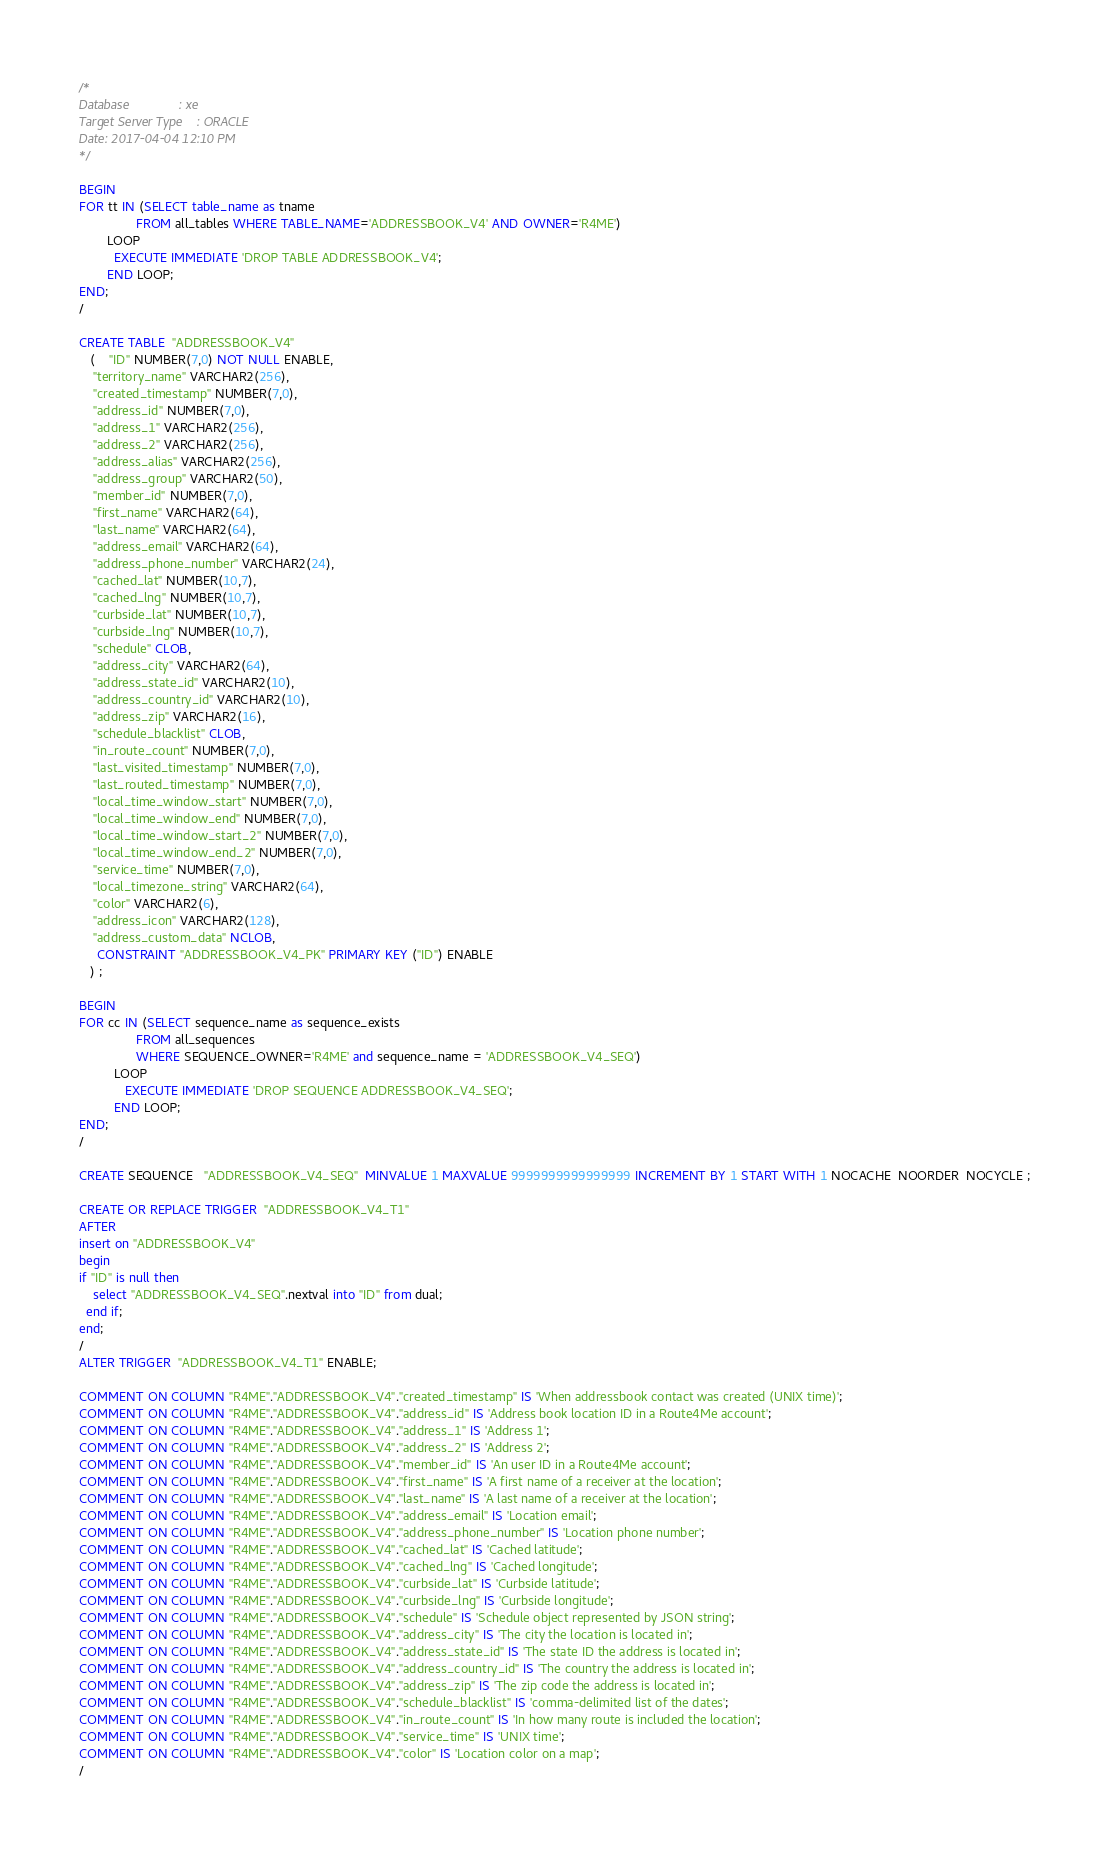Convert code to text. <code><loc_0><loc_0><loc_500><loc_500><_SQL_>/*
Database              : xe
Target Server Type    : ORACLE
Date: 2017-04-04 12:10 PM
*/

BEGIN
FOR tt IN (SELECT table_name as tname
                FROM all_tables WHERE TABLE_NAME='ADDRESSBOOK_V4' AND OWNER='R4ME')
        LOOP
          EXECUTE IMMEDIATE 'DROP TABLE ADDRESSBOOK_V4';
        END LOOP;
END;
/

CREATE TABLE  "ADDRESSBOOK_V4" 
   (	"ID" NUMBER(7,0) NOT NULL ENABLE, 
	"territory_name" VARCHAR2(256), 
	"created_timestamp" NUMBER(7,0), 
	"address_id" NUMBER(7,0), 
	"address_1" VARCHAR2(256), 
	"address_2" VARCHAR2(256), 
	"address_alias" VARCHAR2(256), 
	"address_group" VARCHAR2(50), 
	"member_id" NUMBER(7,0), 
	"first_name" VARCHAR2(64), 
	"last_name" VARCHAR2(64), 
	"address_email" VARCHAR2(64), 
	"address_phone_number" VARCHAR2(24), 
	"cached_lat" NUMBER(10,7), 
	"cached_lng" NUMBER(10,7), 
	"curbside_lat" NUMBER(10,7), 
	"curbside_lng" NUMBER(10,7), 
	"schedule" CLOB, 
	"address_city" VARCHAR2(64), 
	"address_state_id" VARCHAR2(10), 
	"address_country_id" VARCHAR2(10), 
	"address_zip" VARCHAR2(16), 
	"schedule_blacklist" CLOB, 
	"in_route_count" NUMBER(7,0), 
	"last_visited_timestamp" NUMBER(7,0), 
	"last_routed_timestamp" NUMBER(7,0), 
	"local_time_window_start" NUMBER(7,0), 
	"local_time_window_end" NUMBER(7,0), 
	"local_time_window_start_2" NUMBER(7,0), 
	"local_time_window_end_2" NUMBER(7,0), 
	"service_time" NUMBER(7,0), 
	"local_timezone_string" VARCHAR2(64), 
	"color" VARCHAR2(6), 
	"address_icon" VARCHAR2(128), 
	"address_custom_data" NCLOB, 
	 CONSTRAINT "ADDRESSBOOK_V4_PK" PRIMARY KEY ("ID") ENABLE
   ) ;
   
BEGIN
FOR cc IN (SELECT sequence_name as sequence_exists 
                FROM all_sequences
                WHERE SEQUENCE_OWNER='R4ME' and sequence_name = 'ADDRESSBOOK_V4_SEQ')
          LOOP
             EXECUTE IMMEDIATE 'DROP SEQUENCE ADDRESSBOOK_V4_SEQ';
          END LOOP;
END;
/

CREATE SEQUENCE   "ADDRESSBOOK_V4_SEQ"  MINVALUE 1 MAXVALUE 9999999999999999 INCREMENT BY 1 START WITH 1 NOCACHE  NOORDER  NOCYCLE ;
   
CREATE OR REPLACE TRIGGER  "ADDRESSBOOK_V4_T1" 
AFTER
insert on "ADDRESSBOOK_V4"
begin
if "ID" is null then 
    select "ADDRESSBOOK_V4_SEQ".nextval into "ID" from dual; 
  end if; 
end;
/
ALTER TRIGGER  "ADDRESSBOOK_V4_T1" ENABLE;

COMMENT ON COLUMN "R4ME"."ADDRESSBOOK_V4"."created_timestamp" IS 'When addressbook contact was created (UNIX time)';
COMMENT ON COLUMN "R4ME"."ADDRESSBOOK_V4"."address_id" IS 'Address book location ID in a Route4Me account';
COMMENT ON COLUMN "R4ME"."ADDRESSBOOK_V4"."address_1" IS 'Address 1';
COMMENT ON COLUMN "R4ME"."ADDRESSBOOK_V4"."address_2" IS 'Address 2';
COMMENT ON COLUMN "R4ME"."ADDRESSBOOK_V4"."member_id" IS 'An user ID in a Route4Me account';
COMMENT ON COLUMN "R4ME"."ADDRESSBOOK_V4"."first_name" IS 'A first name of a receiver at the location';
COMMENT ON COLUMN "R4ME"."ADDRESSBOOK_V4"."last_name" IS 'A last name of a receiver at the location';
COMMENT ON COLUMN "R4ME"."ADDRESSBOOK_V4"."address_email" IS 'Location email';
COMMENT ON COLUMN "R4ME"."ADDRESSBOOK_V4"."address_phone_number" IS 'Location phone number';
COMMENT ON COLUMN "R4ME"."ADDRESSBOOK_V4"."cached_lat" IS 'Cached latitude';
COMMENT ON COLUMN "R4ME"."ADDRESSBOOK_V4"."cached_lng" IS 'Cached longitude';
COMMENT ON COLUMN "R4ME"."ADDRESSBOOK_V4"."curbside_lat" IS 'Curbside latitude';
COMMENT ON COLUMN "R4ME"."ADDRESSBOOK_V4"."curbside_lng" IS 'Curbside longitude';
COMMENT ON COLUMN "R4ME"."ADDRESSBOOK_V4"."schedule" IS 'Schedule object represented by JSON string';
COMMENT ON COLUMN "R4ME"."ADDRESSBOOK_V4"."address_city" IS 'The city the location is located in';
COMMENT ON COLUMN "R4ME"."ADDRESSBOOK_V4"."address_state_id" IS 'The state ID the address is located in';
COMMENT ON COLUMN "R4ME"."ADDRESSBOOK_V4"."address_country_id" IS 'The country the address is located in';
COMMENT ON COLUMN "R4ME"."ADDRESSBOOK_V4"."address_zip" IS 'The zip code the address is located in';
COMMENT ON COLUMN "R4ME"."ADDRESSBOOK_V4"."schedule_blacklist" IS 'comma-delimited list of the dates';
COMMENT ON COLUMN "R4ME"."ADDRESSBOOK_V4"."in_route_count" IS 'In how many route is included the location';
COMMENT ON COLUMN "R4ME"."ADDRESSBOOK_V4"."service_time" IS 'UNIX time';
COMMENT ON COLUMN "R4ME"."ADDRESSBOOK_V4"."color" IS 'Location color on a map';
/</code> 